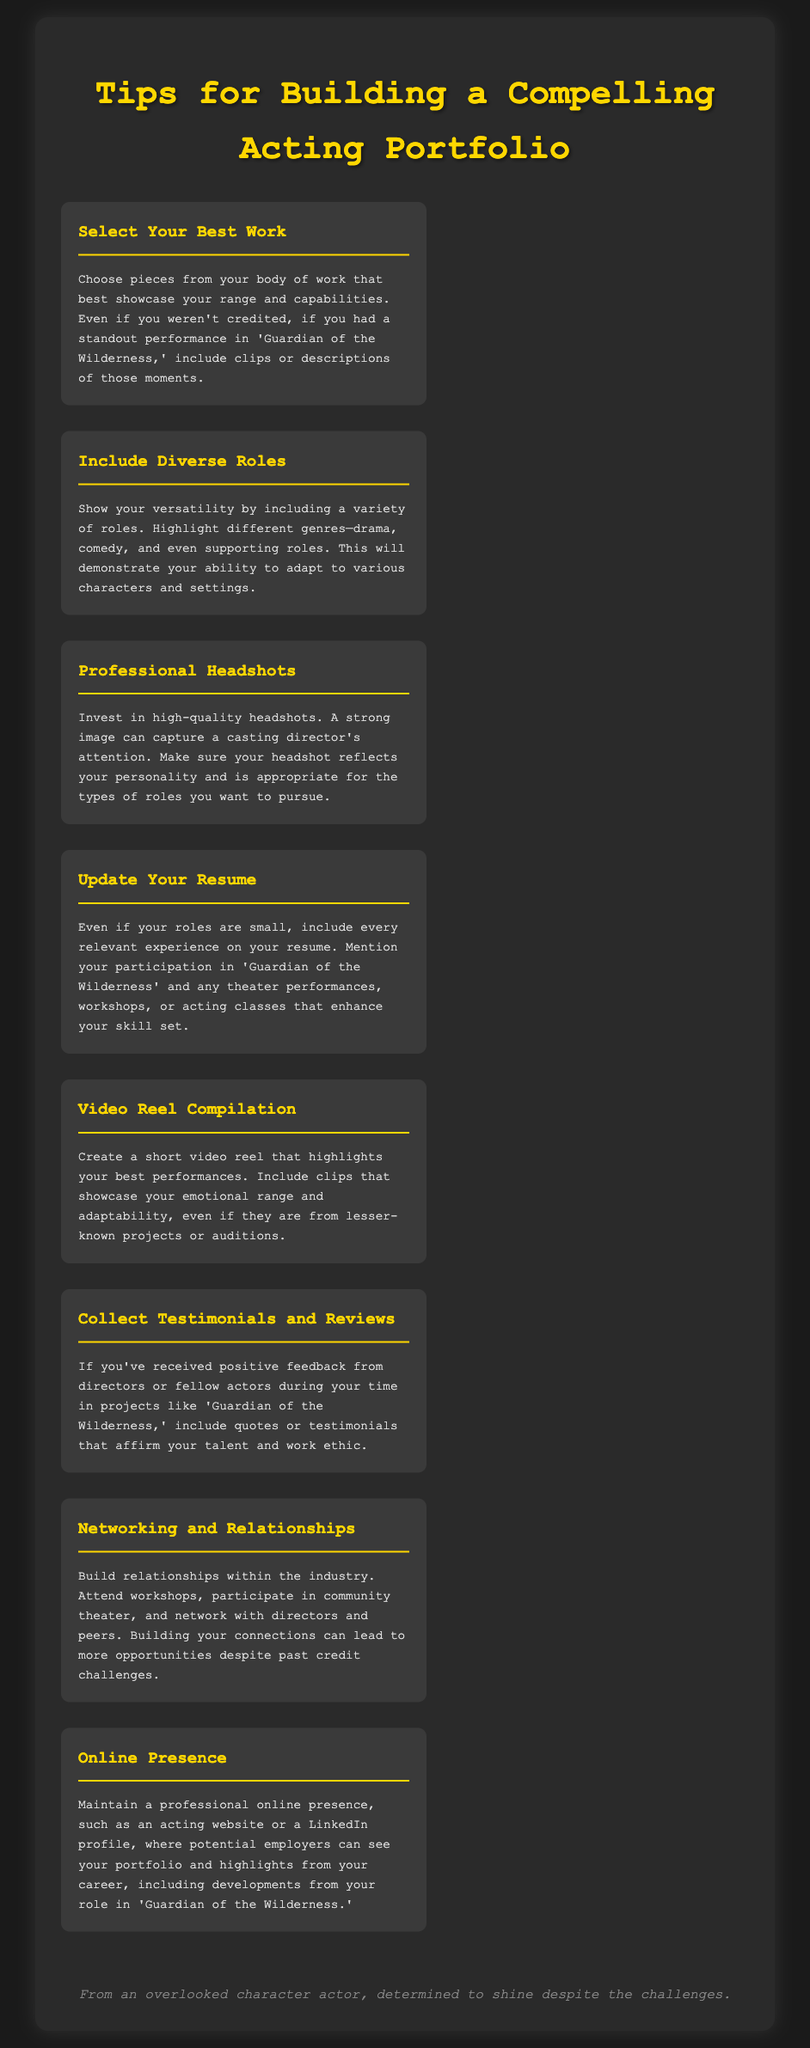What are the two main categories of work to showcase? The document suggests selecting your best work and including diverse roles to showcase range and adaptability.
Answer: Best work and diverse roles What should be included in a video reel? A video reel should highlight best performances and showcase emotional range and adaptability.
Answer: Best performances What is a crucial aspect of headshots mentioned? The document emphasizes that a strong image can capture a casting director's attention.
Answer: Strong image How can one demonstrate versatility in their portfolio? Including a variety of roles across different genres like drama and comedy demonstrates versatility.
Answer: Variety of roles What does the document recommend for maintaining a professional online presence? It suggests having an acting website or a LinkedIn profile to showcase the portfolio.
Answer: Acting website or LinkedIn profile What can be included to reinforce your talent in the portfolio? Testimonials or positive feedback from directors or actors can reinforce talent.
Answer: Testimonials or positive feedback How is networking defined in the context of this document? Networking involves building relationships within the industry to lead to more opportunities.
Answer: Building relationships What is emphasized about updating one's resume? It states that every relevant experience should be included, no matter how small.
Answer: Include every relevant experience 